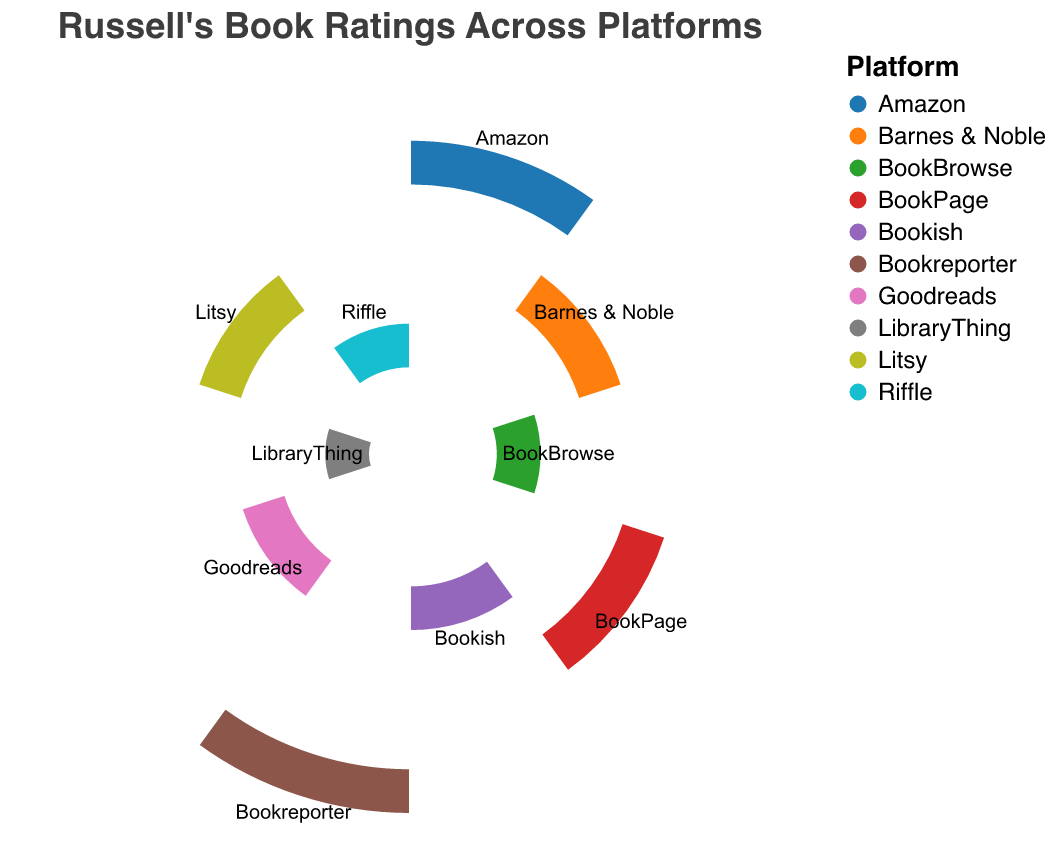What's the title of the chart? The title is displayed at the top of the chart, usually in a larger font size to denote its importance.
Answer: Russell's Book Ratings Across Platforms Which platform has the highest average rating? Looking at the lengths of the bars or the highest label in the chart helps to identify the platform with the maximum rating. The longest bar usually represents the highest value.
Answer: Bookreporter What is the average rating for Amazon? By finding the segment labeled "Amazon," we can read or infer the rating from the reference points around the circle.
Answer: 4.5 Which two platforms have the same average rating of 4.3? By noting the ratings on the chart and matching values, we can identify the two platforms.
Answer: Barnes & Noble and Litsy How many platforms have an average rating of 4.2? The task involves counting the segments with the rating of 4.2 shown on the chart.
Answer: 2 What is the difference in the average rating between the highest-rated and the lowest-rated platforms? Locate the highest and lowest ratings and subtract the lowest from the highest. The highest is 4.6 (Bookreporter) and the lowest is 4.0 (LibraryThing), so 4.6 - 4.0 = 0.6
Answer: 0.6 Which platform has a lower average rating, BookBrowse or Riffle? Compare the average ratings of the two mentioned platforms.
Answer: Both have the same rating of 4.1 Is Goodreads rated higher or lower than BookPage? By comparing the segments for Goodreads and BookPage, we determine their relative ratings. Goodreads is 4.2 and BookPage is 4.4.
Answer: Lower If you merge the ratings of Litsy and Riffle, what would be their combined value? Add the ratings of Litsy (4.3) and Riffle (4.1). 4.3 + 4.1 = 8.4
Answer: 8.4 Which platforms have a higher rating than Bookish? Identify the platforms with ratings higher than Bookish's 4.2 by comparison.
Answer: Amazon, Barnes & Noble, BookPage, Bookreporter, Litsy 